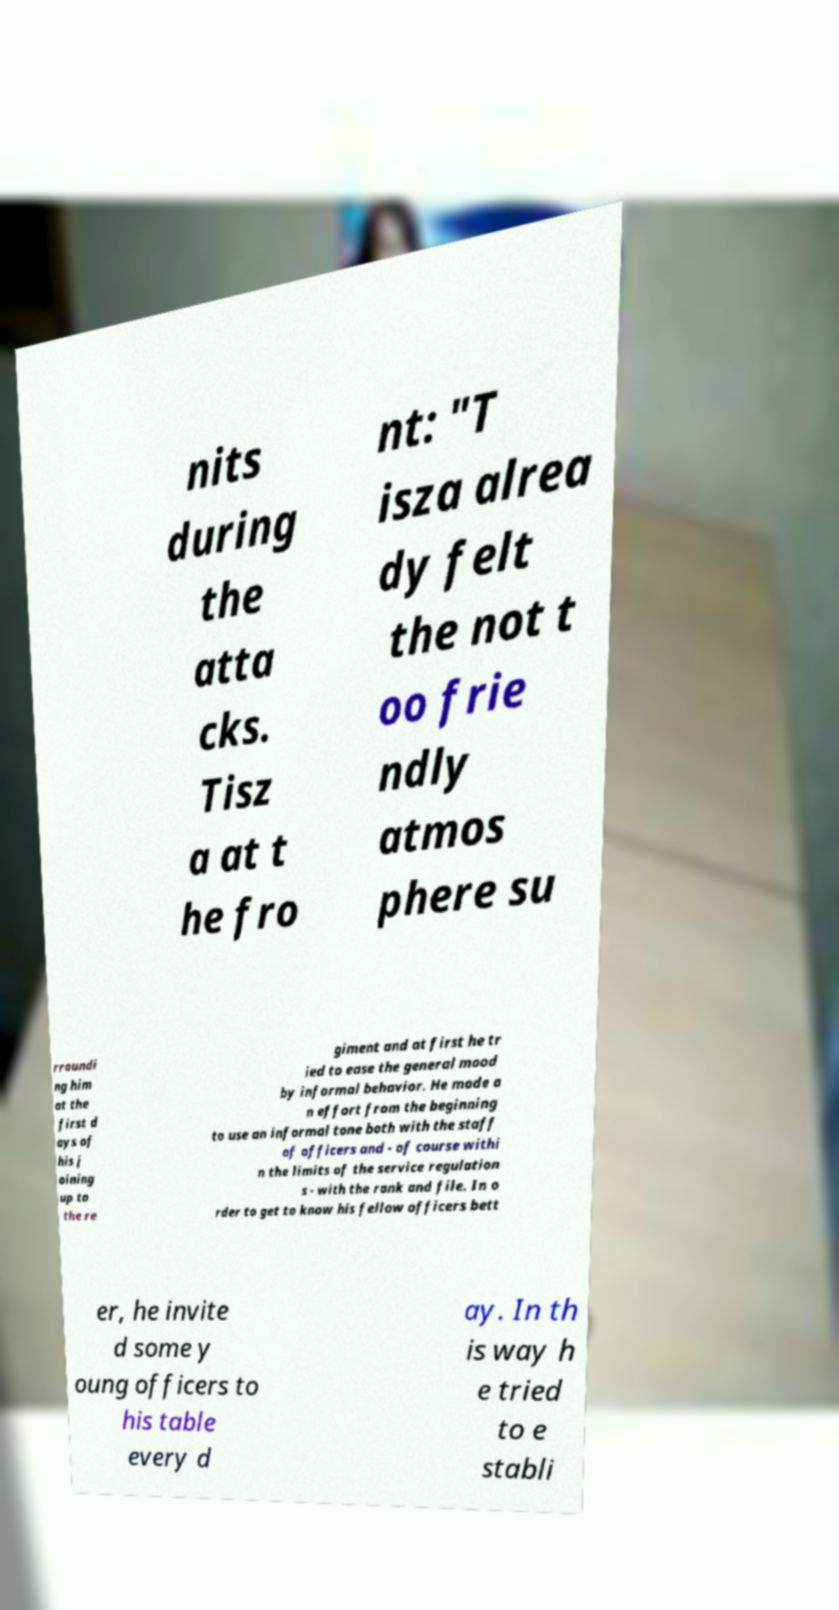Can you read and provide the text displayed in the image?This photo seems to have some interesting text. Can you extract and type it out for me? nits during the atta cks. Tisz a at t he fro nt: "T isza alrea dy felt the not t oo frie ndly atmos phere su rroundi ng him at the first d ays of his j oining up to the re giment and at first he tr ied to ease the general mood by informal behavior. He made a n effort from the beginning to use an informal tone both with the staff of officers and - of course withi n the limits of the service regulation s - with the rank and file. In o rder to get to know his fellow officers bett er, he invite d some y oung officers to his table every d ay. In th is way h e tried to e stabli 